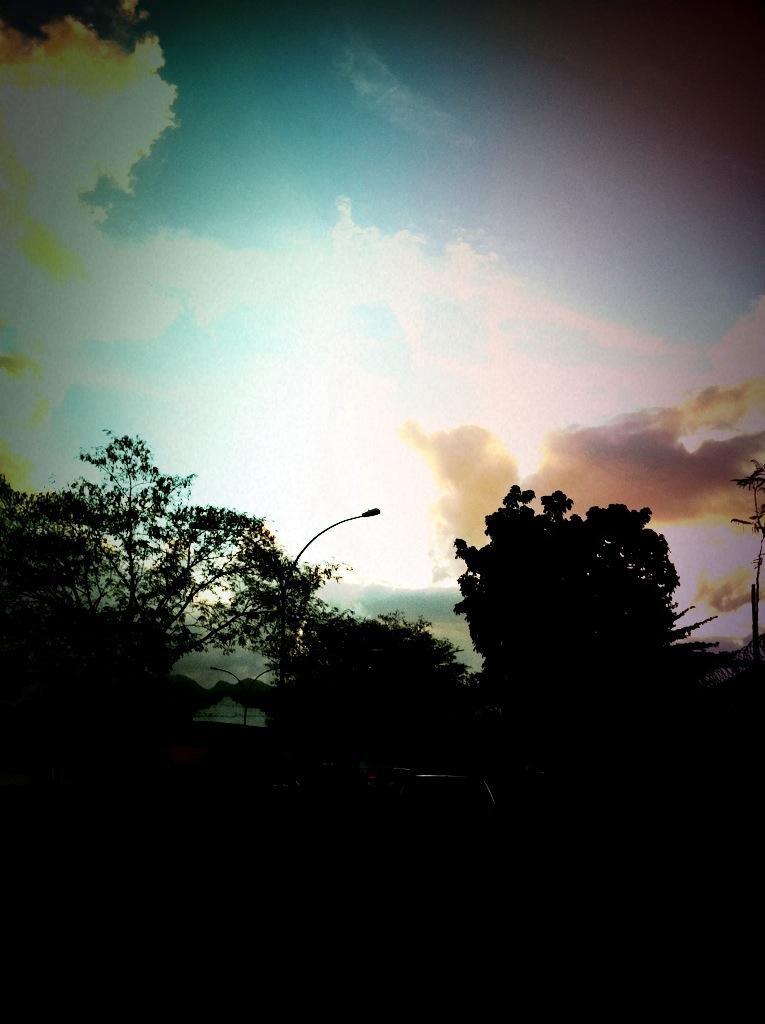Could you give a brief overview of what you see in this image? In this image, I can see the street lights and trees. In the background there is the sky. 